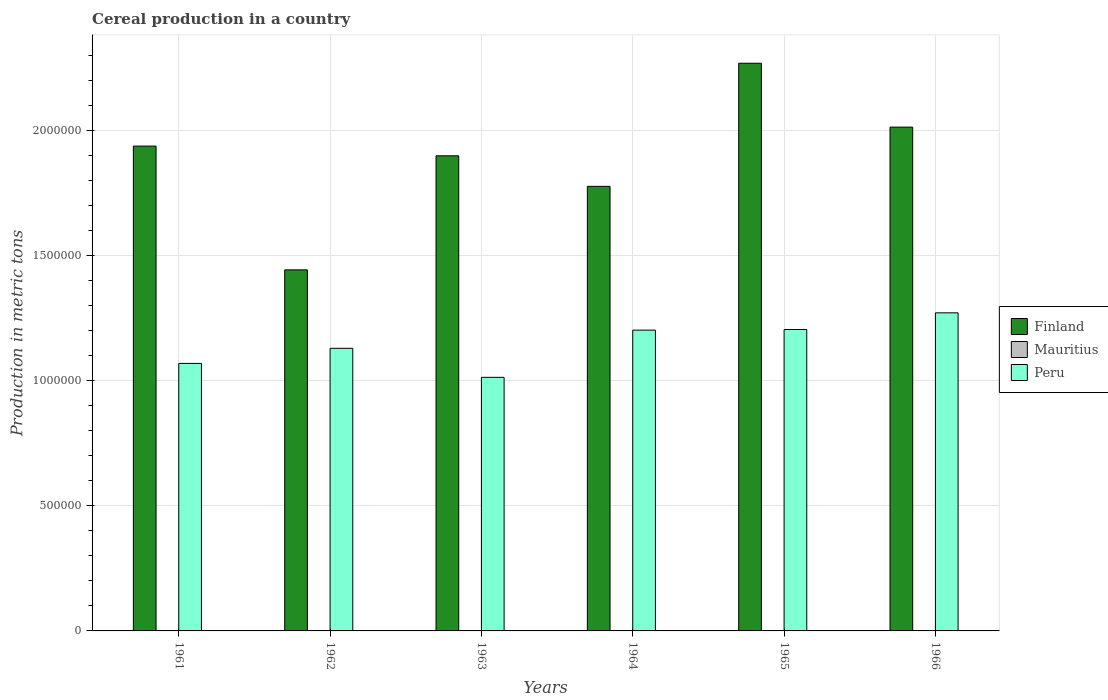How many groups of bars are there?
Offer a terse response. 6. Are the number of bars per tick equal to the number of legend labels?
Your answer should be compact. Yes. How many bars are there on the 4th tick from the left?
Provide a succinct answer. 3. How many bars are there on the 5th tick from the right?
Your answer should be very brief. 3. What is the label of the 3rd group of bars from the left?
Your response must be concise. 1963. What is the total cereal production in Finland in 1966?
Give a very brief answer. 2.02e+06. Across all years, what is the maximum total cereal production in Mauritius?
Ensure brevity in your answer.  457. Across all years, what is the minimum total cereal production in Finland?
Offer a very short reply. 1.44e+06. In which year was the total cereal production in Peru maximum?
Make the answer very short. 1966. In which year was the total cereal production in Peru minimum?
Give a very brief answer. 1963. What is the total total cereal production in Finland in the graph?
Your answer should be very brief. 1.13e+07. What is the difference between the total cereal production in Finland in 1962 and that in 1966?
Make the answer very short. -5.71e+05. What is the difference between the total cereal production in Peru in 1962 and the total cereal production in Mauritius in 1961?
Offer a terse response. 1.13e+06. What is the average total cereal production in Mauritius per year?
Ensure brevity in your answer.  218. In the year 1966, what is the difference between the total cereal production in Mauritius and total cereal production in Finland?
Make the answer very short. -2.01e+06. What is the ratio of the total cereal production in Finland in 1962 to that in 1965?
Offer a terse response. 0.64. Is the difference between the total cereal production in Mauritius in 1962 and 1965 greater than the difference between the total cereal production in Finland in 1962 and 1965?
Provide a short and direct response. Yes. What is the difference between the highest and the second highest total cereal production in Finland?
Offer a terse response. 2.55e+05. What is the difference between the highest and the lowest total cereal production in Peru?
Your answer should be very brief. 2.58e+05. Is the sum of the total cereal production in Mauritius in 1964 and 1965 greater than the maximum total cereal production in Finland across all years?
Make the answer very short. No. What does the 2nd bar from the left in 1964 represents?
Your response must be concise. Mauritius. What does the 2nd bar from the right in 1963 represents?
Provide a succinct answer. Mauritius. Is it the case that in every year, the sum of the total cereal production in Mauritius and total cereal production in Finland is greater than the total cereal production in Peru?
Offer a terse response. Yes. Are the values on the major ticks of Y-axis written in scientific E-notation?
Offer a terse response. No. How many legend labels are there?
Provide a short and direct response. 3. How are the legend labels stacked?
Your answer should be very brief. Vertical. What is the title of the graph?
Your response must be concise. Cereal production in a country. What is the label or title of the X-axis?
Offer a terse response. Years. What is the label or title of the Y-axis?
Ensure brevity in your answer.  Production in metric tons. What is the Production in metric tons of Finland in 1961?
Keep it short and to the point. 1.94e+06. What is the Production in metric tons of Mauritius in 1961?
Your answer should be compact. 180. What is the Production in metric tons in Peru in 1961?
Provide a short and direct response. 1.07e+06. What is the Production in metric tons of Finland in 1962?
Offer a very short reply. 1.44e+06. What is the Production in metric tons in Mauritius in 1962?
Your response must be concise. 203. What is the Production in metric tons of Peru in 1962?
Offer a very short reply. 1.13e+06. What is the Production in metric tons in Finland in 1963?
Provide a succinct answer. 1.90e+06. What is the Production in metric tons of Mauritius in 1963?
Your answer should be very brief. 147. What is the Production in metric tons of Peru in 1963?
Offer a very short reply. 1.01e+06. What is the Production in metric tons in Finland in 1964?
Give a very brief answer. 1.78e+06. What is the Production in metric tons in Peru in 1964?
Make the answer very short. 1.20e+06. What is the Production in metric tons of Finland in 1965?
Ensure brevity in your answer.  2.27e+06. What is the Production in metric tons of Mauritius in 1965?
Make the answer very short. 296. What is the Production in metric tons of Peru in 1965?
Offer a very short reply. 1.21e+06. What is the Production in metric tons of Finland in 1966?
Offer a very short reply. 2.02e+06. What is the Production in metric tons of Mauritius in 1966?
Make the answer very short. 457. What is the Production in metric tons of Peru in 1966?
Ensure brevity in your answer.  1.27e+06. Across all years, what is the maximum Production in metric tons in Finland?
Your answer should be very brief. 2.27e+06. Across all years, what is the maximum Production in metric tons in Mauritius?
Keep it short and to the point. 457. Across all years, what is the maximum Production in metric tons in Peru?
Offer a terse response. 1.27e+06. Across all years, what is the minimum Production in metric tons of Finland?
Provide a succinct answer. 1.44e+06. Across all years, what is the minimum Production in metric tons in Peru?
Keep it short and to the point. 1.01e+06. What is the total Production in metric tons in Finland in the graph?
Offer a very short reply. 1.13e+07. What is the total Production in metric tons in Mauritius in the graph?
Provide a short and direct response. 1308. What is the total Production in metric tons of Peru in the graph?
Make the answer very short. 6.90e+06. What is the difference between the Production in metric tons in Finland in 1961 and that in 1962?
Your response must be concise. 4.95e+05. What is the difference between the Production in metric tons of Peru in 1961 and that in 1962?
Offer a very short reply. -6.05e+04. What is the difference between the Production in metric tons of Finland in 1961 and that in 1963?
Keep it short and to the point. 3.88e+04. What is the difference between the Production in metric tons in Peru in 1961 and that in 1963?
Give a very brief answer. 5.57e+04. What is the difference between the Production in metric tons in Finland in 1961 and that in 1964?
Keep it short and to the point. 1.61e+05. What is the difference between the Production in metric tons in Mauritius in 1961 and that in 1964?
Your answer should be very brief. 155. What is the difference between the Production in metric tons of Peru in 1961 and that in 1964?
Your answer should be very brief. -1.33e+05. What is the difference between the Production in metric tons of Finland in 1961 and that in 1965?
Ensure brevity in your answer.  -3.31e+05. What is the difference between the Production in metric tons of Mauritius in 1961 and that in 1965?
Your response must be concise. -116. What is the difference between the Production in metric tons in Peru in 1961 and that in 1965?
Offer a terse response. -1.36e+05. What is the difference between the Production in metric tons in Finland in 1961 and that in 1966?
Provide a succinct answer. -7.59e+04. What is the difference between the Production in metric tons of Mauritius in 1961 and that in 1966?
Ensure brevity in your answer.  -277. What is the difference between the Production in metric tons of Peru in 1961 and that in 1966?
Keep it short and to the point. -2.02e+05. What is the difference between the Production in metric tons in Finland in 1962 and that in 1963?
Make the answer very short. -4.56e+05. What is the difference between the Production in metric tons of Mauritius in 1962 and that in 1963?
Keep it short and to the point. 56. What is the difference between the Production in metric tons in Peru in 1962 and that in 1963?
Your answer should be very brief. 1.16e+05. What is the difference between the Production in metric tons in Finland in 1962 and that in 1964?
Make the answer very short. -3.34e+05. What is the difference between the Production in metric tons of Mauritius in 1962 and that in 1964?
Give a very brief answer. 178. What is the difference between the Production in metric tons of Peru in 1962 and that in 1964?
Your answer should be compact. -7.27e+04. What is the difference between the Production in metric tons of Finland in 1962 and that in 1965?
Keep it short and to the point. -8.27e+05. What is the difference between the Production in metric tons of Mauritius in 1962 and that in 1965?
Ensure brevity in your answer.  -93. What is the difference between the Production in metric tons of Peru in 1962 and that in 1965?
Provide a succinct answer. -7.52e+04. What is the difference between the Production in metric tons in Finland in 1962 and that in 1966?
Your answer should be very brief. -5.71e+05. What is the difference between the Production in metric tons of Mauritius in 1962 and that in 1966?
Keep it short and to the point. -254. What is the difference between the Production in metric tons of Peru in 1962 and that in 1966?
Provide a succinct answer. -1.42e+05. What is the difference between the Production in metric tons of Finland in 1963 and that in 1964?
Make the answer very short. 1.22e+05. What is the difference between the Production in metric tons of Mauritius in 1963 and that in 1964?
Keep it short and to the point. 122. What is the difference between the Production in metric tons in Peru in 1963 and that in 1964?
Offer a terse response. -1.89e+05. What is the difference between the Production in metric tons of Finland in 1963 and that in 1965?
Give a very brief answer. -3.70e+05. What is the difference between the Production in metric tons in Mauritius in 1963 and that in 1965?
Your answer should be compact. -149. What is the difference between the Production in metric tons of Peru in 1963 and that in 1965?
Offer a very short reply. -1.91e+05. What is the difference between the Production in metric tons in Finland in 1963 and that in 1966?
Offer a terse response. -1.15e+05. What is the difference between the Production in metric tons of Mauritius in 1963 and that in 1966?
Offer a very short reply. -310. What is the difference between the Production in metric tons of Peru in 1963 and that in 1966?
Offer a very short reply. -2.58e+05. What is the difference between the Production in metric tons of Finland in 1964 and that in 1965?
Provide a short and direct response. -4.92e+05. What is the difference between the Production in metric tons in Mauritius in 1964 and that in 1965?
Give a very brief answer. -271. What is the difference between the Production in metric tons in Peru in 1964 and that in 1965?
Your answer should be compact. -2520. What is the difference between the Production in metric tons of Finland in 1964 and that in 1966?
Provide a succinct answer. -2.37e+05. What is the difference between the Production in metric tons in Mauritius in 1964 and that in 1966?
Provide a short and direct response. -432. What is the difference between the Production in metric tons in Peru in 1964 and that in 1966?
Ensure brevity in your answer.  -6.92e+04. What is the difference between the Production in metric tons in Finland in 1965 and that in 1966?
Ensure brevity in your answer.  2.55e+05. What is the difference between the Production in metric tons in Mauritius in 1965 and that in 1966?
Your answer should be very brief. -161. What is the difference between the Production in metric tons in Peru in 1965 and that in 1966?
Offer a very short reply. -6.67e+04. What is the difference between the Production in metric tons of Finland in 1961 and the Production in metric tons of Mauritius in 1962?
Ensure brevity in your answer.  1.94e+06. What is the difference between the Production in metric tons of Finland in 1961 and the Production in metric tons of Peru in 1962?
Your response must be concise. 8.09e+05. What is the difference between the Production in metric tons of Mauritius in 1961 and the Production in metric tons of Peru in 1962?
Ensure brevity in your answer.  -1.13e+06. What is the difference between the Production in metric tons of Finland in 1961 and the Production in metric tons of Mauritius in 1963?
Offer a terse response. 1.94e+06. What is the difference between the Production in metric tons of Finland in 1961 and the Production in metric tons of Peru in 1963?
Your response must be concise. 9.25e+05. What is the difference between the Production in metric tons of Mauritius in 1961 and the Production in metric tons of Peru in 1963?
Offer a very short reply. -1.01e+06. What is the difference between the Production in metric tons in Finland in 1961 and the Production in metric tons in Mauritius in 1964?
Offer a very short reply. 1.94e+06. What is the difference between the Production in metric tons of Finland in 1961 and the Production in metric tons of Peru in 1964?
Keep it short and to the point. 7.36e+05. What is the difference between the Production in metric tons of Mauritius in 1961 and the Production in metric tons of Peru in 1964?
Keep it short and to the point. -1.20e+06. What is the difference between the Production in metric tons of Finland in 1961 and the Production in metric tons of Mauritius in 1965?
Offer a terse response. 1.94e+06. What is the difference between the Production in metric tons of Finland in 1961 and the Production in metric tons of Peru in 1965?
Provide a succinct answer. 7.34e+05. What is the difference between the Production in metric tons in Mauritius in 1961 and the Production in metric tons in Peru in 1965?
Keep it short and to the point. -1.21e+06. What is the difference between the Production in metric tons of Finland in 1961 and the Production in metric tons of Mauritius in 1966?
Provide a succinct answer. 1.94e+06. What is the difference between the Production in metric tons of Finland in 1961 and the Production in metric tons of Peru in 1966?
Offer a terse response. 6.67e+05. What is the difference between the Production in metric tons of Mauritius in 1961 and the Production in metric tons of Peru in 1966?
Your response must be concise. -1.27e+06. What is the difference between the Production in metric tons in Finland in 1962 and the Production in metric tons in Mauritius in 1963?
Your answer should be very brief. 1.44e+06. What is the difference between the Production in metric tons in Finland in 1962 and the Production in metric tons in Peru in 1963?
Provide a short and direct response. 4.30e+05. What is the difference between the Production in metric tons in Mauritius in 1962 and the Production in metric tons in Peru in 1963?
Your answer should be very brief. -1.01e+06. What is the difference between the Production in metric tons in Finland in 1962 and the Production in metric tons in Mauritius in 1964?
Your answer should be compact. 1.44e+06. What is the difference between the Production in metric tons in Finland in 1962 and the Production in metric tons in Peru in 1964?
Your answer should be compact. 2.41e+05. What is the difference between the Production in metric tons of Mauritius in 1962 and the Production in metric tons of Peru in 1964?
Your response must be concise. -1.20e+06. What is the difference between the Production in metric tons of Finland in 1962 and the Production in metric tons of Mauritius in 1965?
Offer a very short reply. 1.44e+06. What is the difference between the Production in metric tons of Finland in 1962 and the Production in metric tons of Peru in 1965?
Provide a succinct answer. 2.39e+05. What is the difference between the Production in metric tons of Mauritius in 1962 and the Production in metric tons of Peru in 1965?
Offer a very short reply. -1.21e+06. What is the difference between the Production in metric tons of Finland in 1962 and the Production in metric tons of Mauritius in 1966?
Provide a short and direct response. 1.44e+06. What is the difference between the Production in metric tons of Finland in 1962 and the Production in metric tons of Peru in 1966?
Give a very brief answer. 1.72e+05. What is the difference between the Production in metric tons in Mauritius in 1962 and the Production in metric tons in Peru in 1966?
Provide a succinct answer. -1.27e+06. What is the difference between the Production in metric tons of Finland in 1963 and the Production in metric tons of Mauritius in 1964?
Offer a very short reply. 1.90e+06. What is the difference between the Production in metric tons in Finland in 1963 and the Production in metric tons in Peru in 1964?
Offer a terse response. 6.97e+05. What is the difference between the Production in metric tons of Mauritius in 1963 and the Production in metric tons of Peru in 1964?
Make the answer very short. -1.20e+06. What is the difference between the Production in metric tons of Finland in 1963 and the Production in metric tons of Mauritius in 1965?
Your answer should be very brief. 1.90e+06. What is the difference between the Production in metric tons of Finland in 1963 and the Production in metric tons of Peru in 1965?
Keep it short and to the point. 6.95e+05. What is the difference between the Production in metric tons of Mauritius in 1963 and the Production in metric tons of Peru in 1965?
Your answer should be very brief. -1.21e+06. What is the difference between the Production in metric tons of Finland in 1963 and the Production in metric tons of Mauritius in 1966?
Ensure brevity in your answer.  1.90e+06. What is the difference between the Production in metric tons of Finland in 1963 and the Production in metric tons of Peru in 1966?
Your response must be concise. 6.28e+05. What is the difference between the Production in metric tons of Mauritius in 1963 and the Production in metric tons of Peru in 1966?
Give a very brief answer. -1.27e+06. What is the difference between the Production in metric tons of Finland in 1964 and the Production in metric tons of Mauritius in 1965?
Your response must be concise. 1.78e+06. What is the difference between the Production in metric tons in Finland in 1964 and the Production in metric tons in Peru in 1965?
Ensure brevity in your answer.  5.73e+05. What is the difference between the Production in metric tons in Mauritius in 1964 and the Production in metric tons in Peru in 1965?
Offer a terse response. -1.21e+06. What is the difference between the Production in metric tons in Finland in 1964 and the Production in metric tons in Mauritius in 1966?
Provide a short and direct response. 1.78e+06. What is the difference between the Production in metric tons of Finland in 1964 and the Production in metric tons of Peru in 1966?
Your response must be concise. 5.06e+05. What is the difference between the Production in metric tons in Mauritius in 1964 and the Production in metric tons in Peru in 1966?
Your response must be concise. -1.27e+06. What is the difference between the Production in metric tons of Finland in 1965 and the Production in metric tons of Mauritius in 1966?
Your answer should be compact. 2.27e+06. What is the difference between the Production in metric tons of Finland in 1965 and the Production in metric tons of Peru in 1966?
Offer a terse response. 9.98e+05. What is the difference between the Production in metric tons in Mauritius in 1965 and the Production in metric tons in Peru in 1966?
Provide a short and direct response. -1.27e+06. What is the average Production in metric tons in Finland per year?
Provide a succinct answer. 1.89e+06. What is the average Production in metric tons in Mauritius per year?
Offer a very short reply. 218. What is the average Production in metric tons of Peru per year?
Provide a short and direct response. 1.15e+06. In the year 1961, what is the difference between the Production in metric tons of Finland and Production in metric tons of Mauritius?
Give a very brief answer. 1.94e+06. In the year 1961, what is the difference between the Production in metric tons in Finland and Production in metric tons in Peru?
Give a very brief answer. 8.69e+05. In the year 1961, what is the difference between the Production in metric tons of Mauritius and Production in metric tons of Peru?
Make the answer very short. -1.07e+06. In the year 1962, what is the difference between the Production in metric tons of Finland and Production in metric tons of Mauritius?
Make the answer very short. 1.44e+06. In the year 1962, what is the difference between the Production in metric tons in Finland and Production in metric tons in Peru?
Give a very brief answer. 3.14e+05. In the year 1962, what is the difference between the Production in metric tons in Mauritius and Production in metric tons in Peru?
Provide a short and direct response. -1.13e+06. In the year 1963, what is the difference between the Production in metric tons in Finland and Production in metric tons in Mauritius?
Offer a very short reply. 1.90e+06. In the year 1963, what is the difference between the Production in metric tons in Finland and Production in metric tons in Peru?
Your response must be concise. 8.86e+05. In the year 1963, what is the difference between the Production in metric tons of Mauritius and Production in metric tons of Peru?
Ensure brevity in your answer.  -1.01e+06. In the year 1964, what is the difference between the Production in metric tons of Finland and Production in metric tons of Mauritius?
Give a very brief answer. 1.78e+06. In the year 1964, what is the difference between the Production in metric tons in Finland and Production in metric tons in Peru?
Ensure brevity in your answer.  5.75e+05. In the year 1964, what is the difference between the Production in metric tons of Mauritius and Production in metric tons of Peru?
Provide a succinct answer. -1.20e+06. In the year 1965, what is the difference between the Production in metric tons of Finland and Production in metric tons of Mauritius?
Your answer should be compact. 2.27e+06. In the year 1965, what is the difference between the Production in metric tons of Finland and Production in metric tons of Peru?
Your answer should be very brief. 1.07e+06. In the year 1965, what is the difference between the Production in metric tons of Mauritius and Production in metric tons of Peru?
Provide a short and direct response. -1.21e+06. In the year 1966, what is the difference between the Production in metric tons of Finland and Production in metric tons of Mauritius?
Provide a succinct answer. 2.01e+06. In the year 1966, what is the difference between the Production in metric tons in Finland and Production in metric tons in Peru?
Provide a succinct answer. 7.43e+05. In the year 1966, what is the difference between the Production in metric tons in Mauritius and Production in metric tons in Peru?
Your answer should be very brief. -1.27e+06. What is the ratio of the Production in metric tons in Finland in 1961 to that in 1962?
Give a very brief answer. 1.34. What is the ratio of the Production in metric tons of Mauritius in 1961 to that in 1962?
Your answer should be very brief. 0.89. What is the ratio of the Production in metric tons of Peru in 1961 to that in 1962?
Offer a terse response. 0.95. What is the ratio of the Production in metric tons of Finland in 1961 to that in 1963?
Provide a short and direct response. 1.02. What is the ratio of the Production in metric tons in Mauritius in 1961 to that in 1963?
Your response must be concise. 1.22. What is the ratio of the Production in metric tons of Peru in 1961 to that in 1963?
Provide a succinct answer. 1.05. What is the ratio of the Production in metric tons in Finland in 1961 to that in 1964?
Provide a short and direct response. 1.09. What is the ratio of the Production in metric tons of Mauritius in 1961 to that in 1964?
Provide a succinct answer. 7.2. What is the ratio of the Production in metric tons in Peru in 1961 to that in 1964?
Offer a very short reply. 0.89. What is the ratio of the Production in metric tons in Finland in 1961 to that in 1965?
Make the answer very short. 0.85. What is the ratio of the Production in metric tons of Mauritius in 1961 to that in 1965?
Your answer should be very brief. 0.61. What is the ratio of the Production in metric tons of Peru in 1961 to that in 1965?
Offer a terse response. 0.89. What is the ratio of the Production in metric tons of Finland in 1961 to that in 1966?
Provide a short and direct response. 0.96. What is the ratio of the Production in metric tons of Mauritius in 1961 to that in 1966?
Offer a terse response. 0.39. What is the ratio of the Production in metric tons of Peru in 1961 to that in 1966?
Offer a terse response. 0.84. What is the ratio of the Production in metric tons in Finland in 1962 to that in 1963?
Give a very brief answer. 0.76. What is the ratio of the Production in metric tons in Mauritius in 1962 to that in 1963?
Your answer should be very brief. 1.38. What is the ratio of the Production in metric tons of Peru in 1962 to that in 1963?
Provide a succinct answer. 1.11. What is the ratio of the Production in metric tons of Finland in 1962 to that in 1964?
Your answer should be very brief. 0.81. What is the ratio of the Production in metric tons of Mauritius in 1962 to that in 1964?
Your answer should be compact. 8.12. What is the ratio of the Production in metric tons in Peru in 1962 to that in 1964?
Your answer should be compact. 0.94. What is the ratio of the Production in metric tons of Finland in 1962 to that in 1965?
Keep it short and to the point. 0.64. What is the ratio of the Production in metric tons in Mauritius in 1962 to that in 1965?
Provide a succinct answer. 0.69. What is the ratio of the Production in metric tons of Peru in 1962 to that in 1965?
Keep it short and to the point. 0.94. What is the ratio of the Production in metric tons of Finland in 1962 to that in 1966?
Give a very brief answer. 0.72. What is the ratio of the Production in metric tons in Mauritius in 1962 to that in 1966?
Provide a short and direct response. 0.44. What is the ratio of the Production in metric tons in Peru in 1962 to that in 1966?
Provide a succinct answer. 0.89. What is the ratio of the Production in metric tons in Finland in 1963 to that in 1964?
Your answer should be compact. 1.07. What is the ratio of the Production in metric tons of Mauritius in 1963 to that in 1964?
Your answer should be very brief. 5.88. What is the ratio of the Production in metric tons of Peru in 1963 to that in 1964?
Offer a terse response. 0.84. What is the ratio of the Production in metric tons in Finland in 1963 to that in 1965?
Give a very brief answer. 0.84. What is the ratio of the Production in metric tons of Mauritius in 1963 to that in 1965?
Your answer should be compact. 0.5. What is the ratio of the Production in metric tons of Peru in 1963 to that in 1965?
Offer a very short reply. 0.84. What is the ratio of the Production in metric tons in Finland in 1963 to that in 1966?
Your answer should be very brief. 0.94. What is the ratio of the Production in metric tons of Mauritius in 1963 to that in 1966?
Offer a terse response. 0.32. What is the ratio of the Production in metric tons of Peru in 1963 to that in 1966?
Offer a very short reply. 0.8. What is the ratio of the Production in metric tons in Finland in 1964 to that in 1965?
Give a very brief answer. 0.78. What is the ratio of the Production in metric tons in Mauritius in 1964 to that in 1965?
Your response must be concise. 0.08. What is the ratio of the Production in metric tons of Finland in 1964 to that in 1966?
Offer a terse response. 0.88. What is the ratio of the Production in metric tons of Mauritius in 1964 to that in 1966?
Provide a short and direct response. 0.05. What is the ratio of the Production in metric tons of Peru in 1964 to that in 1966?
Ensure brevity in your answer.  0.95. What is the ratio of the Production in metric tons in Finland in 1965 to that in 1966?
Give a very brief answer. 1.13. What is the ratio of the Production in metric tons in Mauritius in 1965 to that in 1966?
Your answer should be compact. 0.65. What is the ratio of the Production in metric tons in Peru in 1965 to that in 1966?
Your response must be concise. 0.95. What is the difference between the highest and the second highest Production in metric tons of Finland?
Give a very brief answer. 2.55e+05. What is the difference between the highest and the second highest Production in metric tons in Mauritius?
Give a very brief answer. 161. What is the difference between the highest and the second highest Production in metric tons of Peru?
Your response must be concise. 6.67e+04. What is the difference between the highest and the lowest Production in metric tons of Finland?
Provide a short and direct response. 8.27e+05. What is the difference between the highest and the lowest Production in metric tons of Mauritius?
Keep it short and to the point. 432. What is the difference between the highest and the lowest Production in metric tons in Peru?
Give a very brief answer. 2.58e+05. 